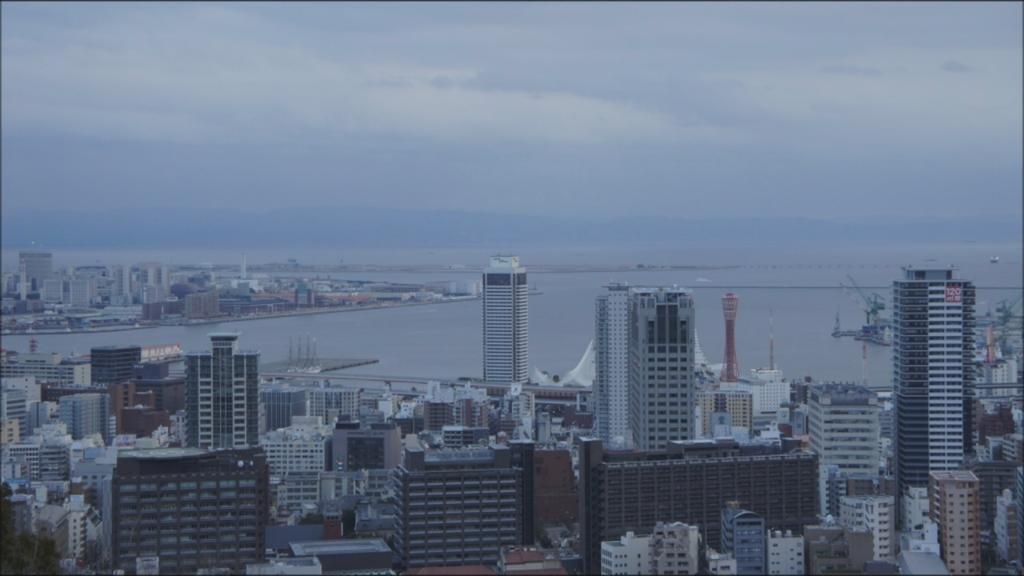Can you describe this image briefly? These are the buildings on the down side of an image. At the top it's a sky. 